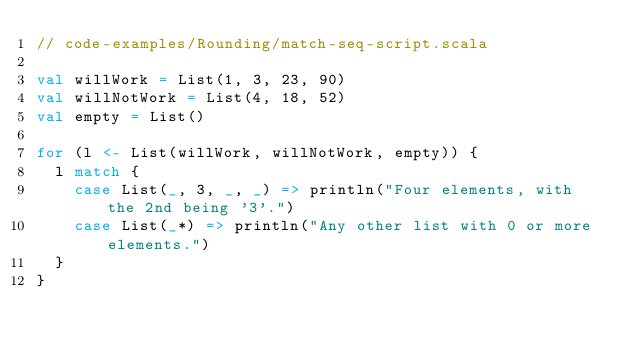Convert code to text. <code><loc_0><loc_0><loc_500><loc_500><_Scala_>// code-examples/Rounding/match-seq-script.scala

val willWork = List(1, 3, 23, 90)
val willNotWork = List(4, 18, 52)
val empty = List()

for (l <- List(willWork, willNotWork, empty)) {
  l match {
    case List(_, 3, _, _) => println("Four elements, with the 2nd being '3'.")
    case List(_*) => println("Any other list with 0 or more elements.")
  }
}
</code> 